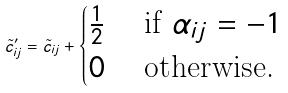<formula> <loc_0><loc_0><loc_500><loc_500>\tilde { c } ^ { \prime } _ { i j } = \tilde { c } _ { i j } + \begin{cases} \frac { 1 } { 2 } & \text { if } \alpha _ { i j } = - 1 \\ 0 & \text { otherwise.} \end{cases}</formula> 